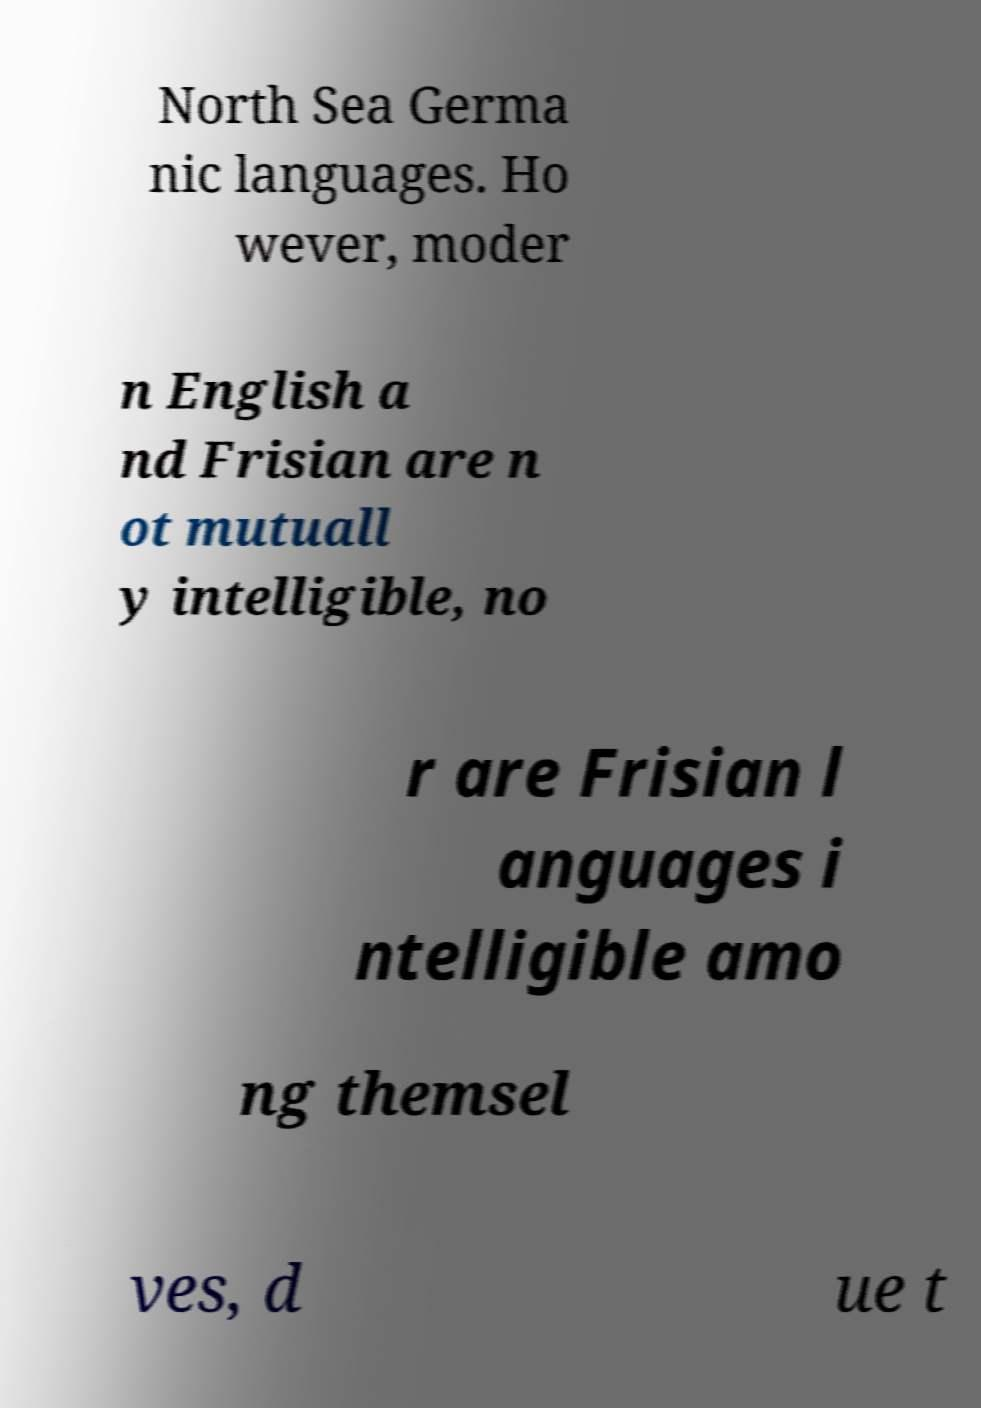For documentation purposes, I need the text within this image transcribed. Could you provide that? North Sea Germa nic languages. Ho wever, moder n English a nd Frisian are n ot mutuall y intelligible, no r are Frisian l anguages i ntelligible amo ng themsel ves, d ue t 